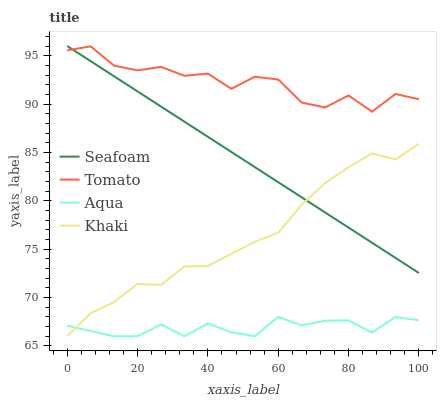Does Aqua have the minimum area under the curve?
Answer yes or no. Yes. Does Tomato have the maximum area under the curve?
Answer yes or no. Yes. Does Khaki have the minimum area under the curve?
Answer yes or no. No. Does Khaki have the maximum area under the curve?
Answer yes or no. No. Is Seafoam the smoothest?
Answer yes or no. Yes. Is Tomato the roughest?
Answer yes or no. Yes. Is Khaki the smoothest?
Answer yes or no. No. Is Khaki the roughest?
Answer yes or no. No. Does Khaki have the lowest value?
Answer yes or no. Yes. Does Seafoam have the lowest value?
Answer yes or no. No. Does Seafoam have the highest value?
Answer yes or no. Yes. Does Khaki have the highest value?
Answer yes or no. No. Is Khaki less than Tomato?
Answer yes or no. Yes. Is Tomato greater than Aqua?
Answer yes or no. Yes. Does Seafoam intersect Khaki?
Answer yes or no. Yes. Is Seafoam less than Khaki?
Answer yes or no. No. Is Seafoam greater than Khaki?
Answer yes or no. No. Does Khaki intersect Tomato?
Answer yes or no. No. 